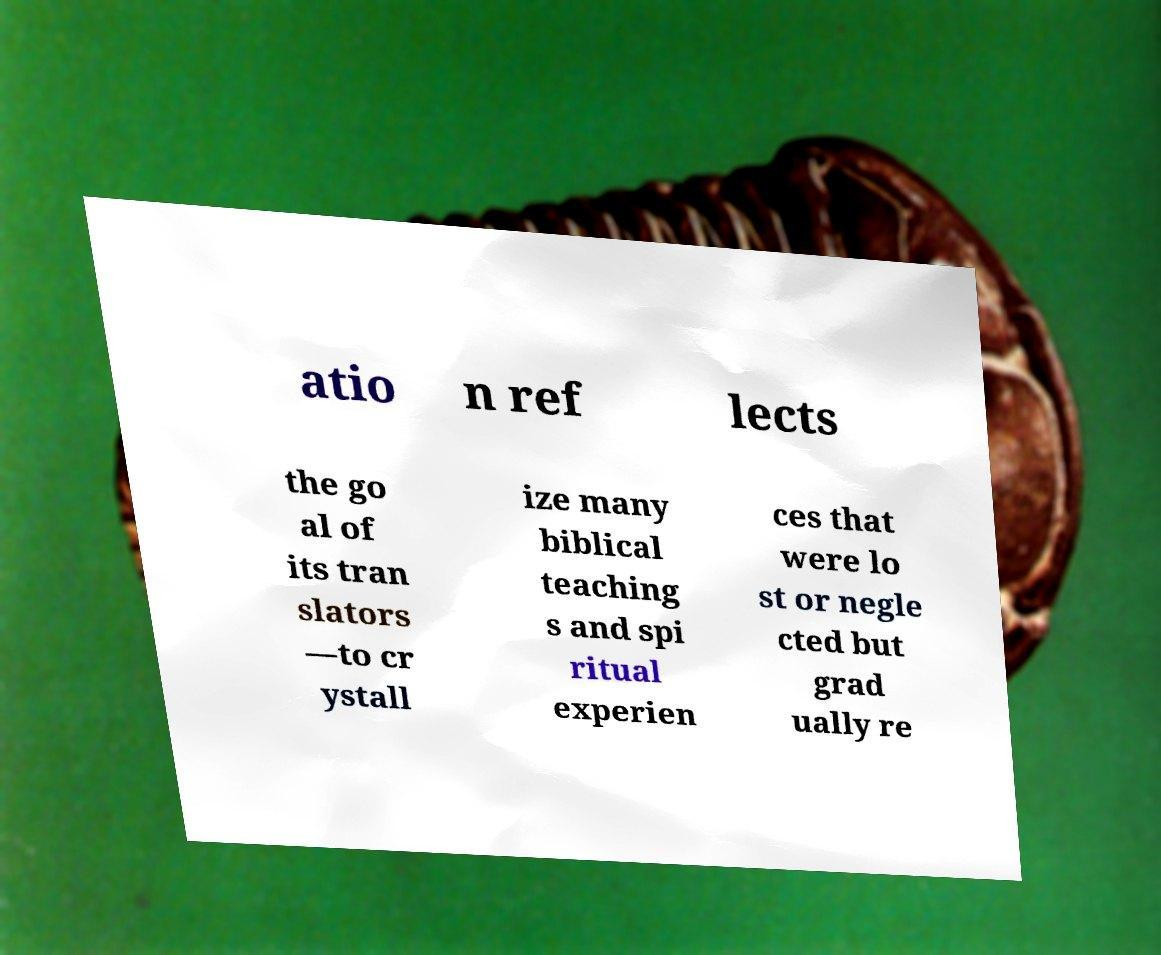Please identify and transcribe the text found in this image. atio n ref lects the go al of its tran slators —to cr ystall ize many biblical teaching s and spi ritual experien ces that were lo st or negle cted but grad ually re 